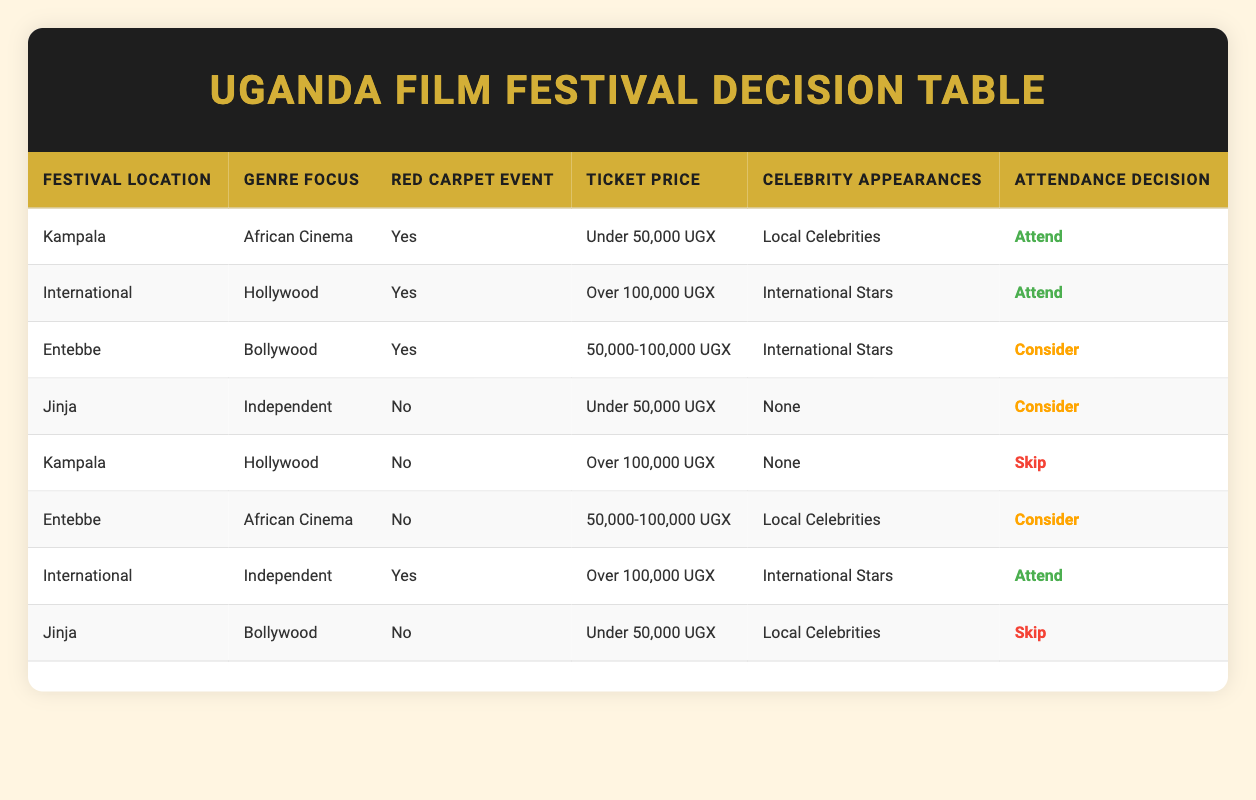What is the attendance decision for the film festival located in Kampala with a focus on African Cinema? The table shows that for the conditions of Kampala, African Cinema, a red carpet event, ticket price under 50,000 UGX, and local celebrities present, the attendance decision is "Attend."
Answer: Attend Which budget range is associated with the decision to consider attending the film festival in Entebbe focused on Bollywood? For Entebbe with Bollywood as the genre focus, the table indicates that the attendance decision is "Consider" when the ticket price is in the range of 50,000-100,000 UGX.
Answer: 50,000-100,000 UGX Does the film festival in Jinja feature local celebrities if the attendance decision is to skip? The table shows that if the festival in Jinja features Bollywood, has no red carpet event, ticket price under 50,000 UGX, and local celebrities are present, the attendance decision is "Skip." Hence, the festival does not feature local celebrities if the decision is to skip.
Answer: No How many film festival attendance scenarios result in a decision to attend? Scanning the table, there are three scenarios where the attendance decision is "Attend": 1) Kampala with African Cinema, 2) International with Hollywood, and 3) International with Independent. Thus, the total is three scenarios.
Answer: 3 In which festival location and genre focus do we see the highest ticket price that results in attendance? The table lists International with Hollywood as the festival location and genre focus which has the attendance decision "Attend" and an associated ticket price of over 100,000 UGX.
Answer: International, Hollywood What percentage of the total entries in the table involve a decision to skip attendance? The table has 8 total entries. The "Skip" attendance decision appears in 3 scenarios: Kampala with Hollywood, Jinja with Bollywood, totaling 3 out of 8. To find the percentage, (3/8) * 100 = 37.5%.
Answer: 37.5% Is there any instance where a festival located in Entebbe can ensure attendance? According to the table, there are no entries from Entebbe that result in an "Attend" decision; therefore, it is concluded there are no instances for attendance in Entebbe.
Answer: No What is the relationship between celebrity appearances and attendance decisions in this table? Analyzing the table, it is noted that when there are local celebrities present at the festivals, there are mixed attendance decisions. Nevertheless, celebrity appearances like "International Stars" tend to guarantee attendance, especially in high-budget scenarios.
Answer: Mixed relationship 